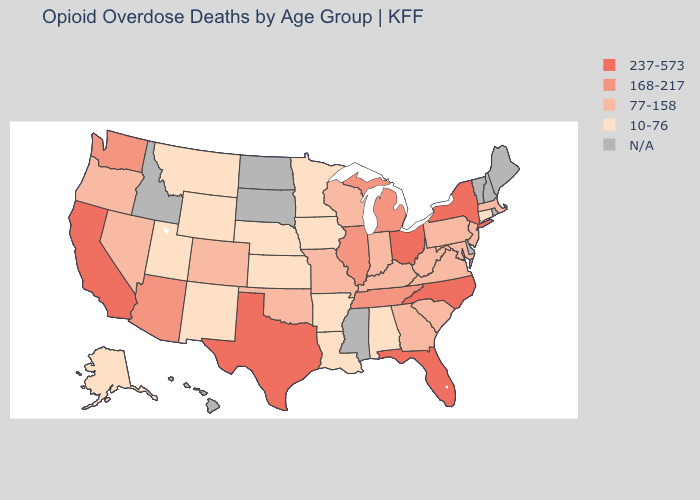Does Oklahoma have the highest value in the South?
Give a very brief answer. No. What is the lowest value in the West?
Short answer required. 10-76. What is the value of Maryland?
Be succinct. 77-158. What is the value of Hawaii?
Answer briefly. N/A. What is the value of South Dakota?
Keep it brief. N/A. Name the states that have a value in the range 237-573?
Answer briefly. California, Florida, New York, North Carolina, Ohio, Texas. What is the value of Maryland?
Quick response, please. 77-158. Does Florida have the highest value in the USA?
Concise answer only. Yes. What is the value of Arizona?
Keep it brief. 168-217. What is the value of North Dakota?
Write a very short answer. N/A. Name the states that have a value in the range N/A?
Concise answer only. Delaware, Hawaii, Idaho, Maine, Mississippi, New Hampshire, North Dakota, Rhode Island, South Dakota, Vermont. What is the highest value in states that border Mississippi?
Write a very short answer. 168-217. 